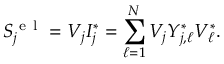<formula> <loc_0><loc_0><loc_500><loc_500>S _ { j } ^ { e l } = V _ { j } I _ { j } ^ { * } = \sum _ { \ell = 1 } ^ { N } V _ { j } Y _ { j , \ell } ^ { * } V _ { \ell } ^ { * } .</formula> 